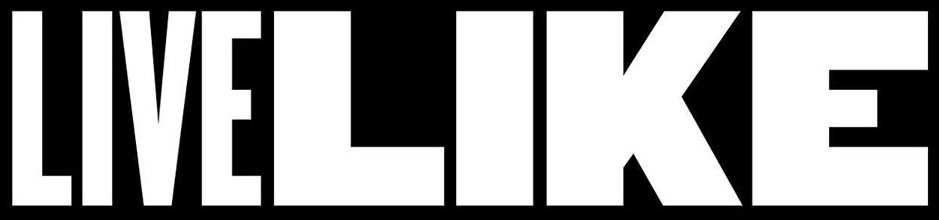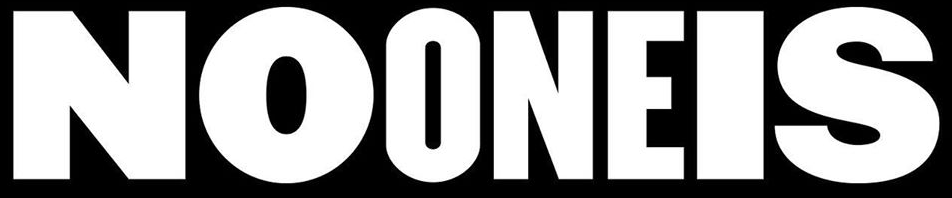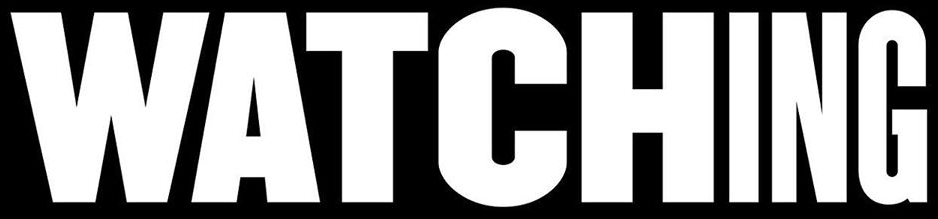What words can you see in these images in sequence, separated by a semicolon? LIVELIKE; NOONEIS; WATCHING 